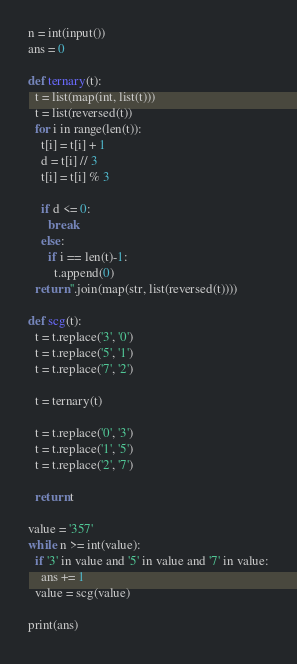Convert code to text. <code><loc_0><loc_0><loc_500><loc_500><_Python_>n = int(input())
ans = 0

def ternary(t):
  t = list(map(int, list(t)))
  t = list(reversed(t))
  for i in range(len(t)):
    t[i] = t[i] + 1
    d = t[i] // 3
    t[i] = t[i] % 3
    
    if d <= 0:
      break
    else:
      if i == len(t)-1:
        t.append(0)
  return ''.join(map(str, list(reversed(t))))

def scg(t):
  t = t.replace('3', '0')
  t = t.replace('5', '1')
  t = t.replace('7', '2')
  
  t = ternary(t)
  
  t = t.replace('0', '3')
  t = t.replace('1', '5')
  t = t.replace('2', '7')
  
  return t

value = '357'
while n >= int(value):
  if '3' in value and '5' in value and '7' in value:
    ans += 1
  value = scg(value)

print(ans)</code> 